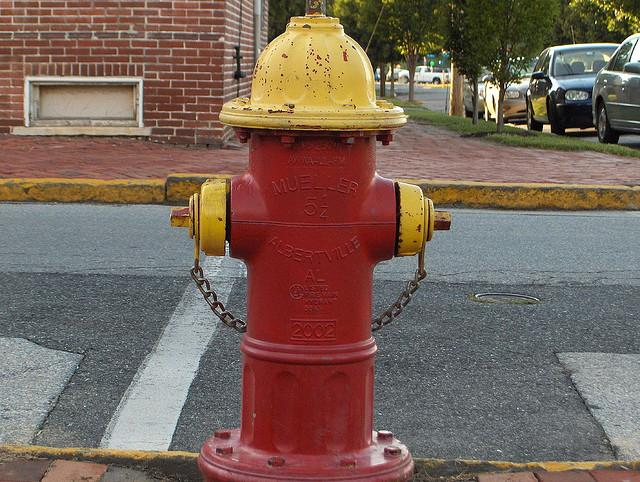The red color of fire hydrant represents what?

Choices:
A) fire level
B) water quality
C) water force
D) none water force 